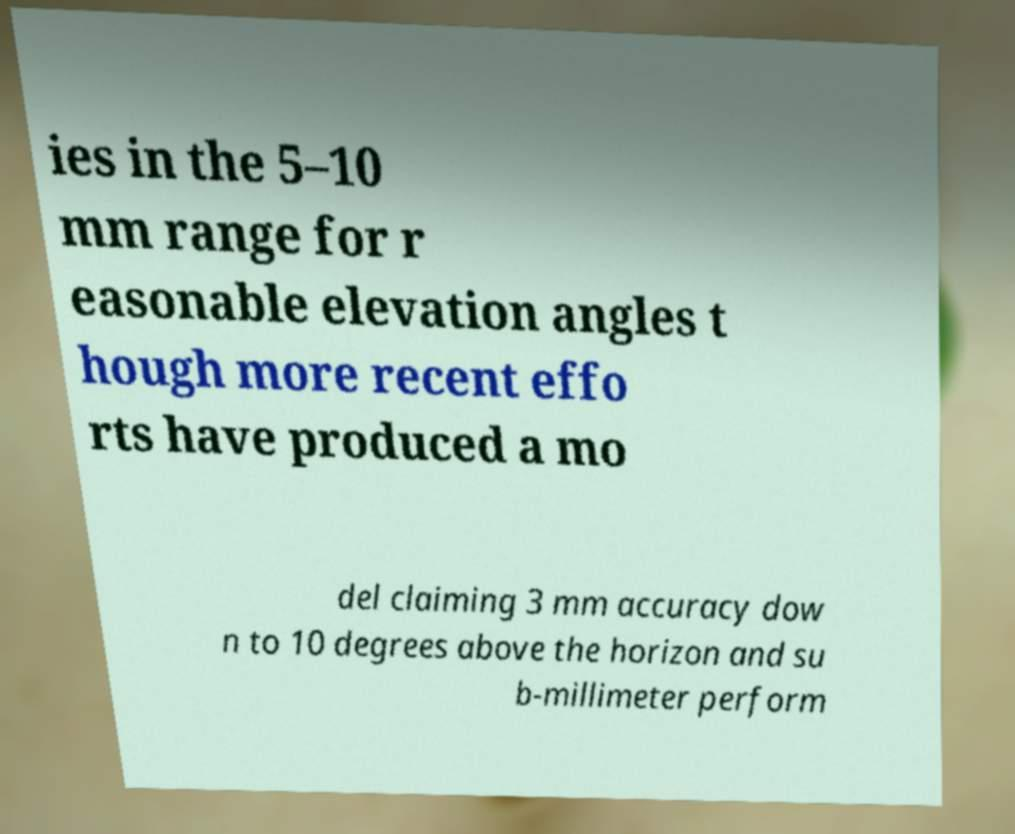Can you accurately transcribe the text from the provided image for me? ies in the 5–10 mm range for r easonable elevation angles t hough more recent effo rts have produced a mo del claiming 3 mm accuracy dow n to 10 degrees above the horizon and su b-millimeter perform 